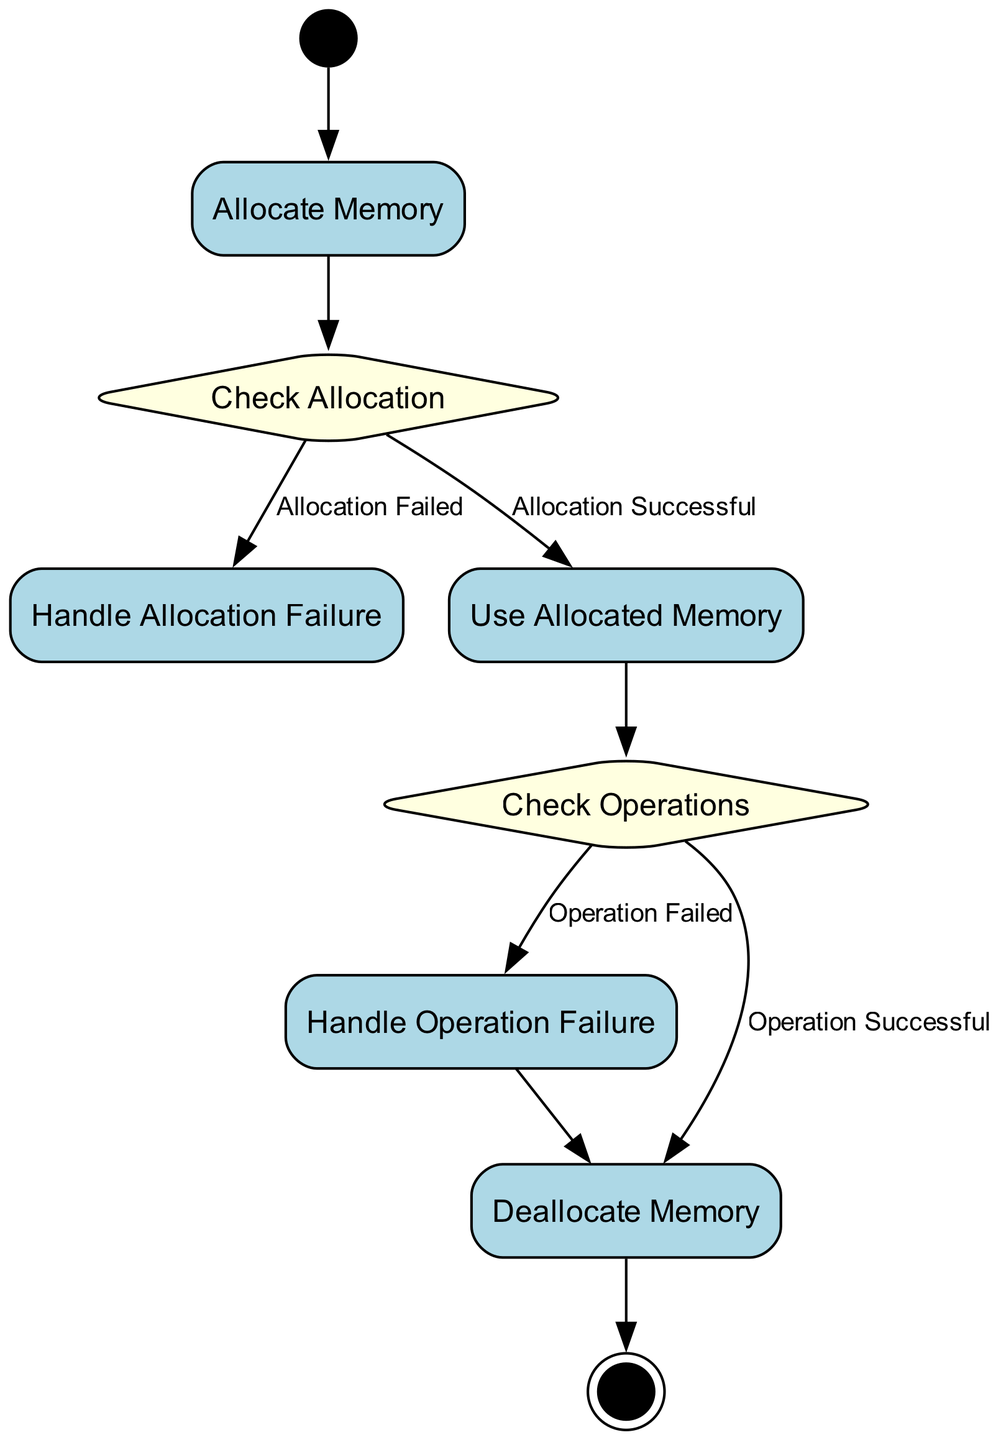What is the first action in the diagram? The initial node is labeled "Start", which indicates the beginning of the process in the activity diagram. The first action that follows "Start" is "Allocate Memory".
Answer: Allocate Memory How many action nodes are present in the diagram? The diagram includes four action nodes: "Allocate Memory", "Handle Allocation Failure", "Use Allocated Memory", and "Deallocate Memory". Therefore, there are four action nodes.
Answer: Four What condition leads to handling allocation failure? The condition that leads to "Handle Allocation Failure" is labeled "Allocation Failed", which is checked after attempting to allocate memory.
Answer: Allocation Failed Which node comes after checking operations if they succeed? If operations on allocated memory are successful, the next action after "Check Operations" is "Deallocate Memory".
Answer: Deallocate Memory How many total nodes are in the diagram? The diagram contains nine nodes, including "Start", "Allocate Memory", "Check Allocation", "Handle Allocation Failure", "Use Allocated Memory", "Check Operations", "Handle Operation Failure", "Deallocate Memory", and "End".
Answer: Nine What happens if the operation on allocated memory fails? If the operation fails, the process flows to "Handle Operation Failure", where failure is managed, after which it proceeds to "Deallocate Memory".
Answer: Handle Operation Failure What type of node is "Check Allocation"? "Check Allocation" is classified as a decision node, as it requires evaluating whether the memory allocation was successful or failed.
Answer: Decision Node What is the last action before reaching the end of the diagram? The final action before reaching the "End" node is "Deallocate Memory". This indicates that all memory has been properly deallocated in the process.
Answer: Deallocate Memory 